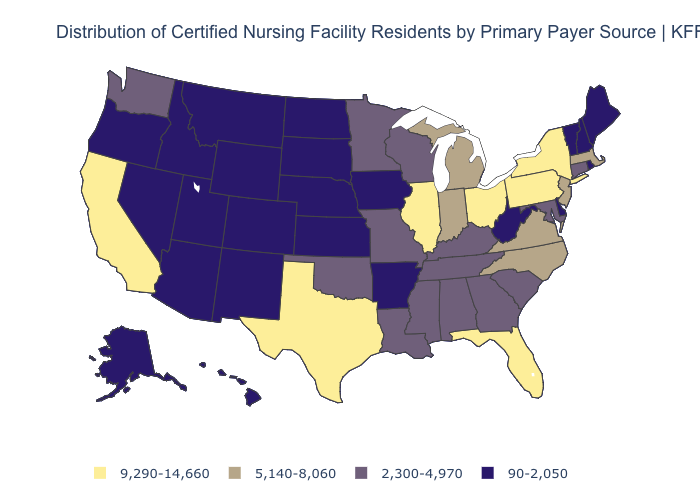What is the value of Oklahoma?
Short answer required. 2,300-4,970. Does California have the highest value in the West?
Write a very short answer. Yes. Does Minnesota have a higher value than Arizona?
Give a very brief answer. Yes. What is the value of Montana?
Be succinct. 90-2,050. Among the states that border Vermont , does Massachusetts have the highest value?
Write a very short answer. No. What is the value of Arkansas?
Short answer required. 90-2,050. What is the value of Connecticut?
Keep it brief. 2,300-4,970. Name the states that have a value in the range 9,290-14,660?
Keep it brief. California, Florida, Illinois, New York, Ohio, Pennsylvania, Texas. Name the states that have a value in the range 2,300-4,970?
Answer briefly. Alabama, Connecticut, Georgia, Kentucky, Louisiana, Maryland, Minnesota, Mississippi, Missouri, Oklahoma, South Carolina, Tennessee, Washington, Wisconsin. What is the lowest value in the MidWest?
Concise answer only. 90-2,050. Name the states that have a value in the range 9,290-14,660?
Answer briefly. California, Florida, Illinois, New York, Ohio, Pennsylvania, Texas. Does New Hampshire have the same value as Nebraska?
Give a very brief answer. Yes. Name the states that have a value in the range 90-2,050?
Concise answer only. Alaska, Arizona, Arkansas, Colorado, Delaware, Hawaii, Idaho, Iowa, Kansas, Maine, Montana, Nebraska, Nevada, New Hampshire, New Mexico, North Dakota, Oregon, Rhode Island, South Dakota, Utah, Vermont, West Virginia, Wyoming. Which states hav the highest value in the MidWest?
Answer briefly. Illinois, Ohio. 